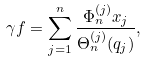<formula> <loc_0><loc_0><loc_500><loc_500>\gamma f = \sum _ { j = 1 } ^ { n } \frac { \Phi _ { n } ^ { ( j ) } x _ { j } } { \Theta _ { n } ^ { ( j ) } ( q _ { j } ) } ,</formula> 